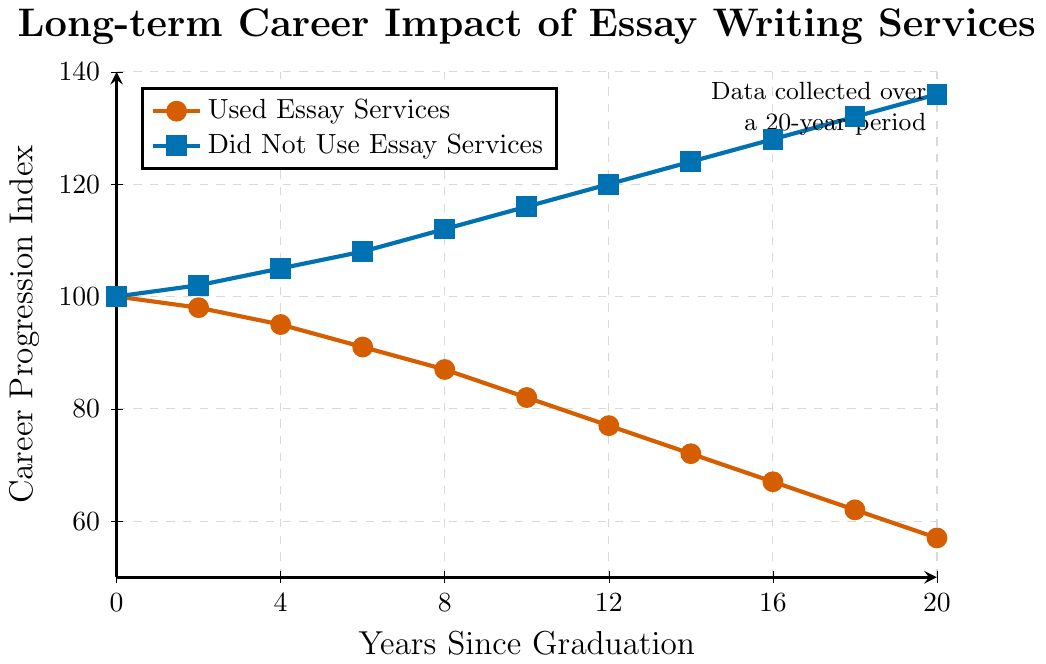Which group shows a higher career progression index after 10 years? From the graph, after 10 years, the career progression index for those who did not use essay writing services is higher than for those who did. The plot shows the values as 116 for the group that did not use the services and 82 for those that did.
Answer: The group that did not use essay services What is the difference in the career progression index between the two groups at the 20-year mark? At the 20-year mark, the career progression index for those who did not use essay writing services is 136, while it is 57 for those who did. The difference is 136 - 57.
Answer: 79 How many points does the career progression index decrease for the group that used essay services from year 0 to year 20? At year 0, the index starts at 100 and decreases to 57 by year 20. The decrease is calculated by subtracting the final value from the initial value: 100 - 57.
Answer: 43 Which group has a faster rate of decline in the career progression index over the 20-year period? By observing the lines, the red line (used essay services) shows a continuous and steep decline, whereas the blue line (did not use essay services) steadily rises. The steeper decline means a faster rate of decline.
Answer: The group that used essay services What is the average career progression index for the group that did not use essay services over the 20 years? To find the average, sum the indices at each time point for the group that did not use essay services and divide by the number of time points. (100 + 102 + 105 + 108 + 112 + 116 + 120 + 124 + 128 + 132 + 136) / 11
Answer: 116.18 At which year do the groups first show a noticeable difference in career progression index? By observing when the lines start to significantly diverge, year 2 shows a minor difference still within margin, but by year 4 there is a more noticeable gap.
Answer: Year 4 How does the career progression index of the group that did not use essay services change from year 6 to year 12? At year 6, the index is 108, and at year 12, it is 120. The change is given by 120 - 108.
Answer: 12 Determine the trend in career progression for the group that used essay services. The red line shows a consistent downward trend from year 0 to year 20, indicating a steady decline in career progression over time. The declines occur at each observed interval.
Answer: Steady decline In which year does the largest single decrease occur for the group that used essay services, and what is the magnitude of this decrease? Observing the red line, between year 8 and year 10, the index drops from 87 to 82. The magnitude is calculated as 87 - 82.
Answer: Year 8 to 10, with a decrease of 5 points 